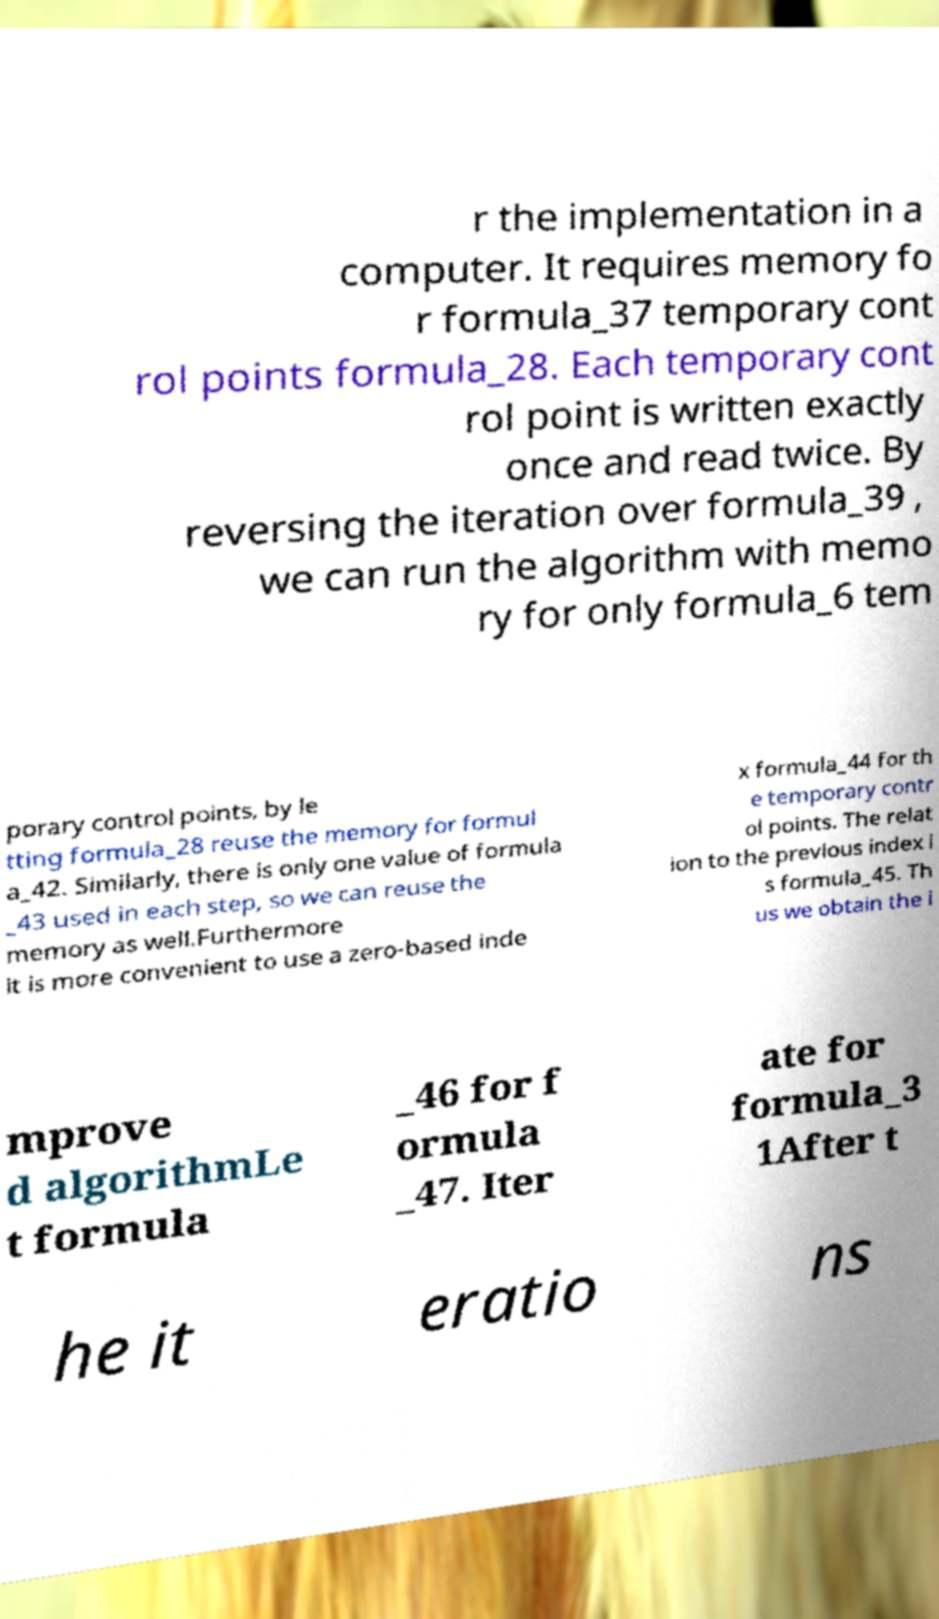Can you read and provide the text displayed in the image?This photo seems to have some interesting text. Can you extract and type it out for me? r the implementation in a computer. It requires memory fo r formula_37 temporary cont rol points formula_28. Each temporary cont rol point is written exactly once and read twice. By reversing the iteration over formula_39 , we can run the algorithm with memo ry for only formula_6 tem porary control points, by le tting formula_28 reuse the memory for formul a_42. Similarly, there is only one value of formula _43 used in each step, so we can reuse the memory as well.Furthermore it is more convenient to use a zero-based inde x formula_44 for th e temporary contr ol points. The relat ion to the previous index i s formula_45. Th us we obtain the i mprove d algorithmLe t formula _46 for f ormula _47. Iter ate for formula_3 1After t he it eratio ns 